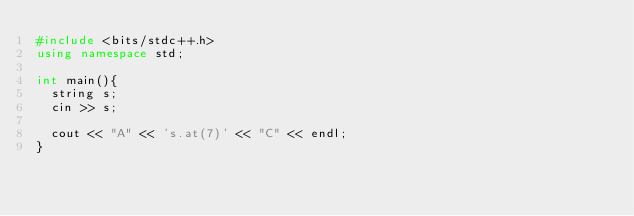<code> <loc_0><loc_0><loc_500><loc_500><_C++_>#include <bits/stdc++.h>
using namespace std;
 
int main(){
  string s;
  cin >> s;
  
  cout << "A" << 's.at(7)' << "C" << endl;
}
</code> 